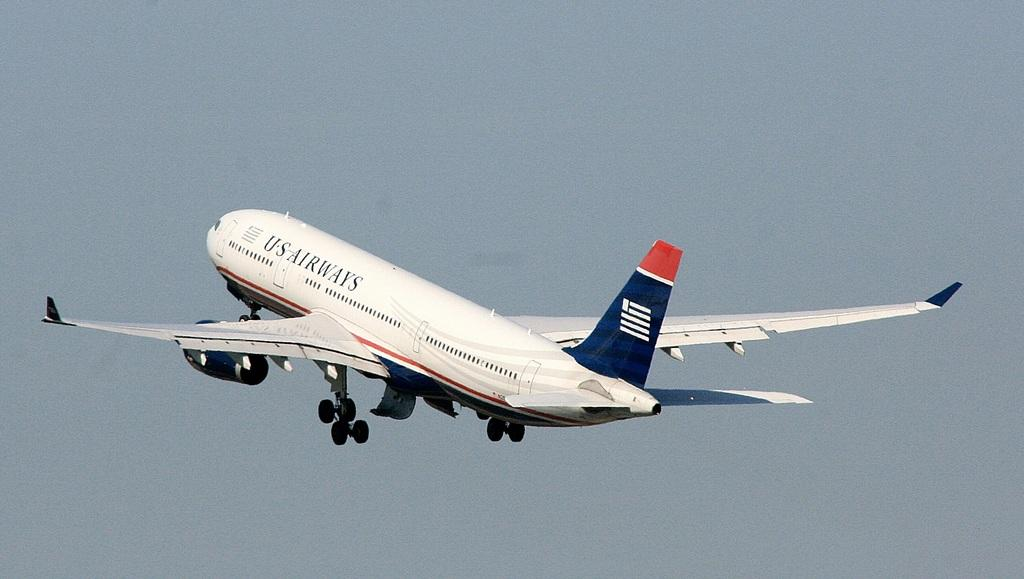What is the main subject of the image? The main subject of the image is an aeroplane. What colors can be seen on the aeroplane? The aeroplane is white, blue, and red in color. What is the aeroplane doing in the image? The aeroplane is flying in the air. What can be seen in the background of the image? The sky is visible in the background of the image. How does the aeroplane attack the grain field in the image? There is no grain field or attack depicted in the image; it features an aeroplane flying in the sky. Can you tell me how fast the aeroplane is running in the image? The aeroplane is not running; it is flying in the air. 